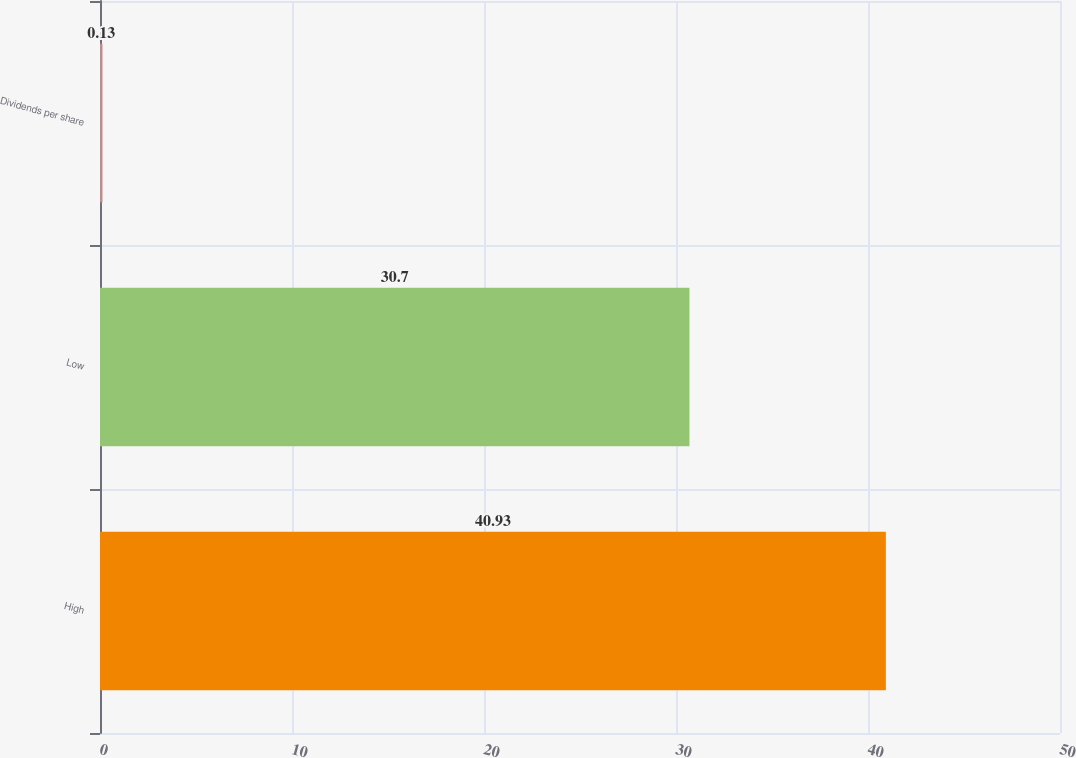<chart> <loc_0><loc_0><loc_500><loc_500><bar_chart><fcel>High<fcel>Low<fcel>Dividends per share<nl><fcel>40.93<fcel>30.7<fcel>0.13<nl></chart> 